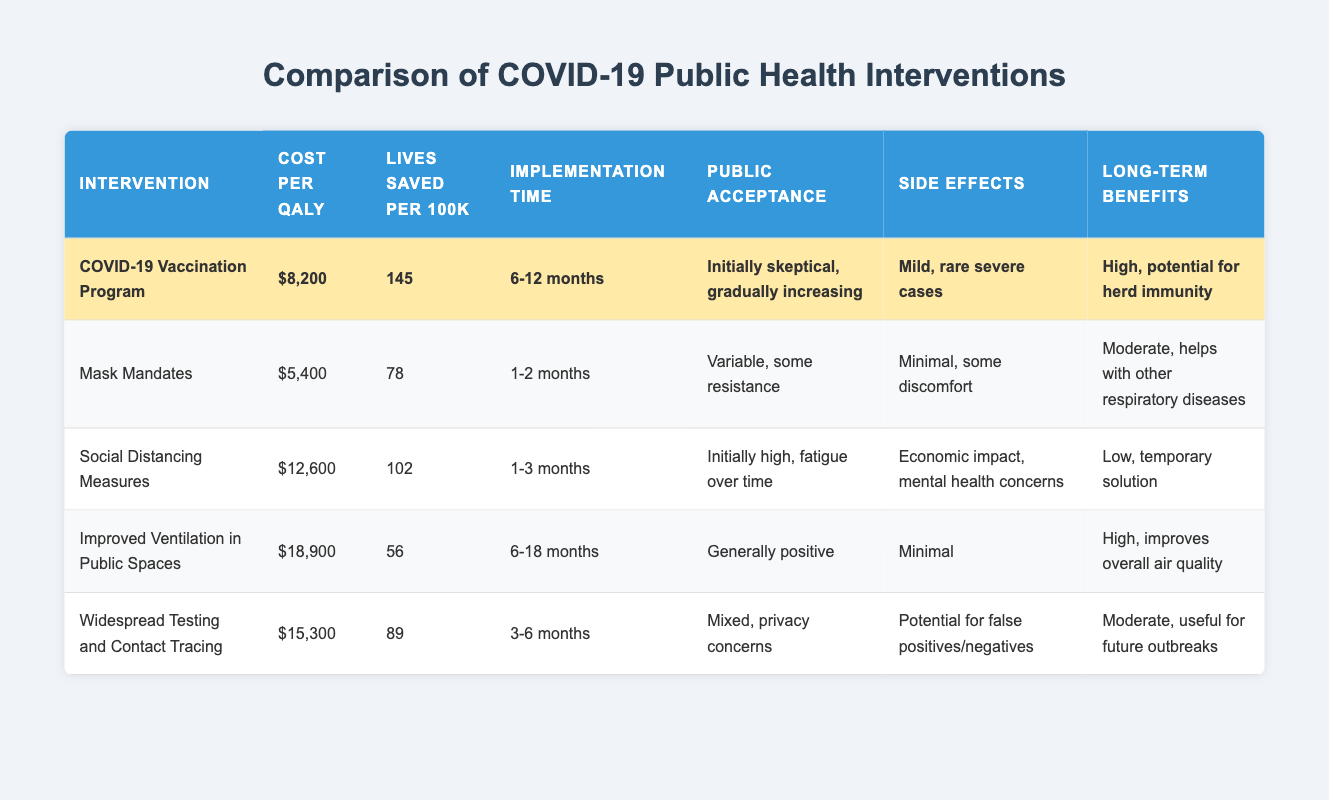What is the cost per QALY for the COVID-19 Vaccination Program? Referring to the table, the cost per QALY for the COVID-19 Vaccination Program is directly listed, which is $8,200.
Answer: $8,200 How many lives are saved per 100k by the Mask Mandates? Looking at the table, the number of lives saved per 100k by the Mask Mandates is given as 78.
Answer: 78 Which intervention has the highest cost per QALY? By comparing the cost per QALY values in the table, Improved Ventilation in Public Spaces has the highest cost per QALY at $18,900.
Answer: Improved Ventilation in Public Spaces Is the public acceptance for the Social Distancing Measures initially high? The table indicates that the public acceptance for Social Distancing Measures was initially high, followed by fatigue over time, confirming the statement as true.
Answer: Yes What is the average number of lives saved per 100k for all interventions listed? Summing the lives saved per 100k across all interventions gives 145 + 78 + 102 + 56 + 89 = 470. Dividing by the number of interventions (5), the average is 470 / 5 = 94.
Answer: 94 Compare the implementation time for Mask Mandates and Widespread Testing and Contact Tracing; which is shorter? The table shows implementation time of 1-2 months for Mask Mandates and 3-6 months for Widespread Testing and Contact Tracing. Since 1-2 months is shorter than 3-6 months, Mask Mandates have a shorter implementation time.
Answer: Mask Mandates What are the long-term benefits of the COVID-19 Vaccination Program? The table states that the long-term benefits of the COVID-19 Vaccination Program are high, with a potential for herd immunity.
Answer: High, potential for herd immunity Are the side effects of Improved Ventilation in Public Spaces considered moderate? The table lists the side effects of Improved Ventilation in Public Spaces as minimal, indicating that the statement is false.
Answer: No Calculate the difference in lives saved per 100k between the COVID-19 Vaccination Program and Improved Ventilation in Public Spaces. Lives saved by the COVID-19 Vaccination Program is 145 and by Improved Ventilation in Public Spaces is 56. The difference is 145 - 56 = 89.
Answer: 89 